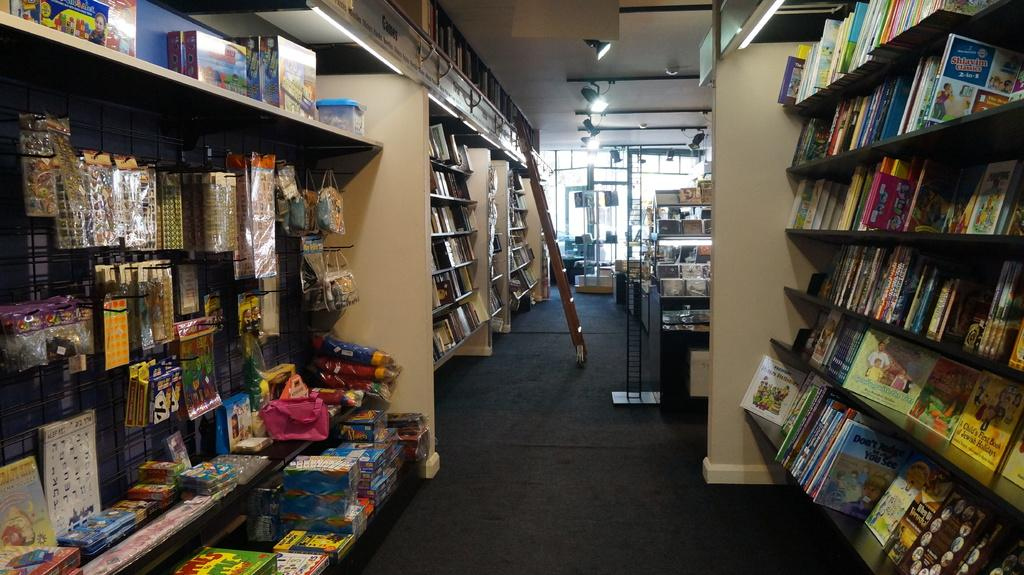What type of items can be seen in the shelves in the image? There are books in the shelves in the image. What can be found on the left side of the image? There are toys on the left side of the image. What is located in the center of the image? There is a ladder in the center of the image. What is present at the top of the image? There are lights on the top of the top of the image. Can you see a pet inside the tent in the image? There is no tent or pet present in the image. What type of roll is being used to support the ladder in the image? There is no roll present in the image; the ladder is standing on its own. 